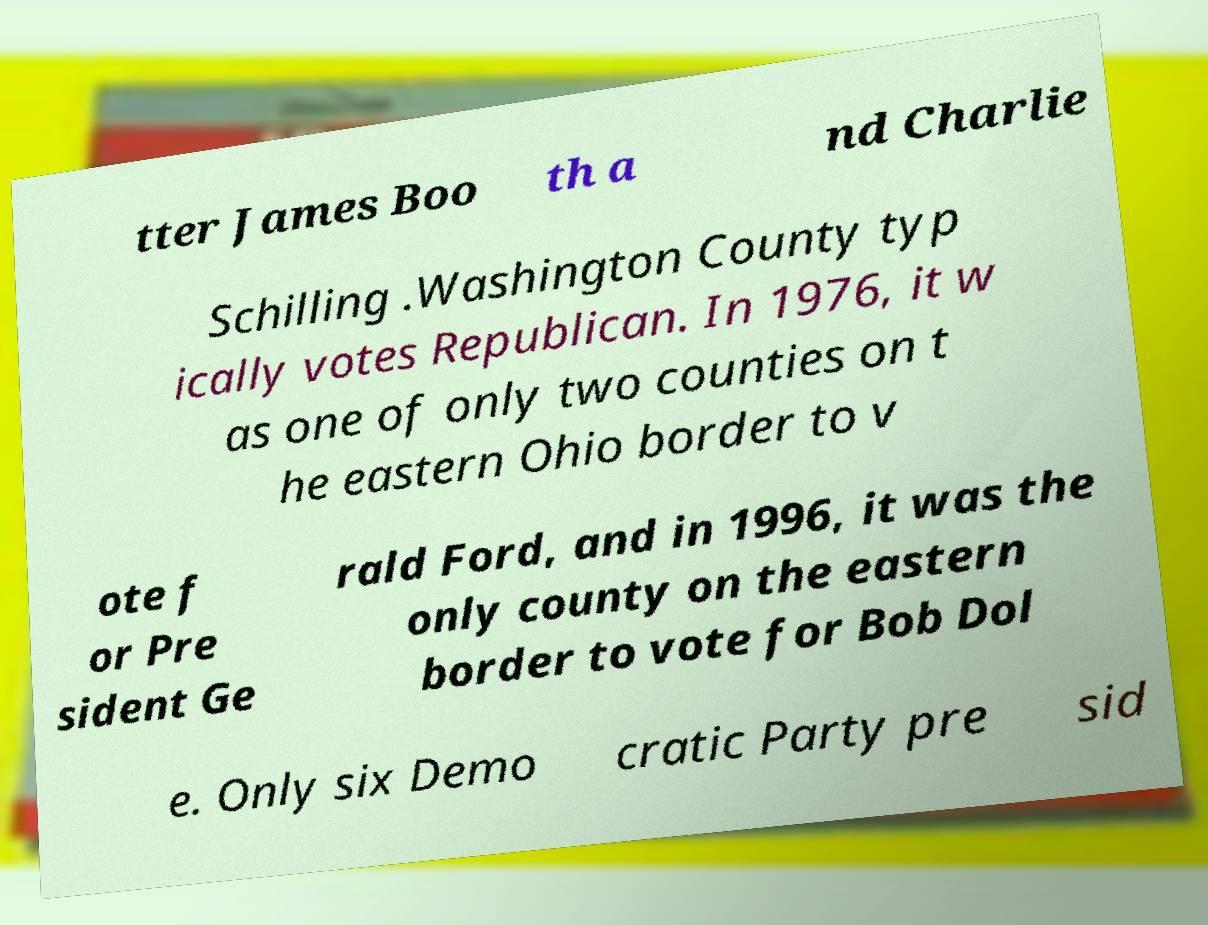Could you assist in decoding the text presented in this image and type it out clearly? tter James Boo th a nd Charlie Schilling .Washington County typ ically votes Republican. In 1976, it w as one of only two counties on t he eastern Ohio border to v ote f or Pre sident Ge rald Ford, and in 1996, it was the only county on the eastern border to vote for Bob Dol e. Only six Demo cratic Party pre sid 